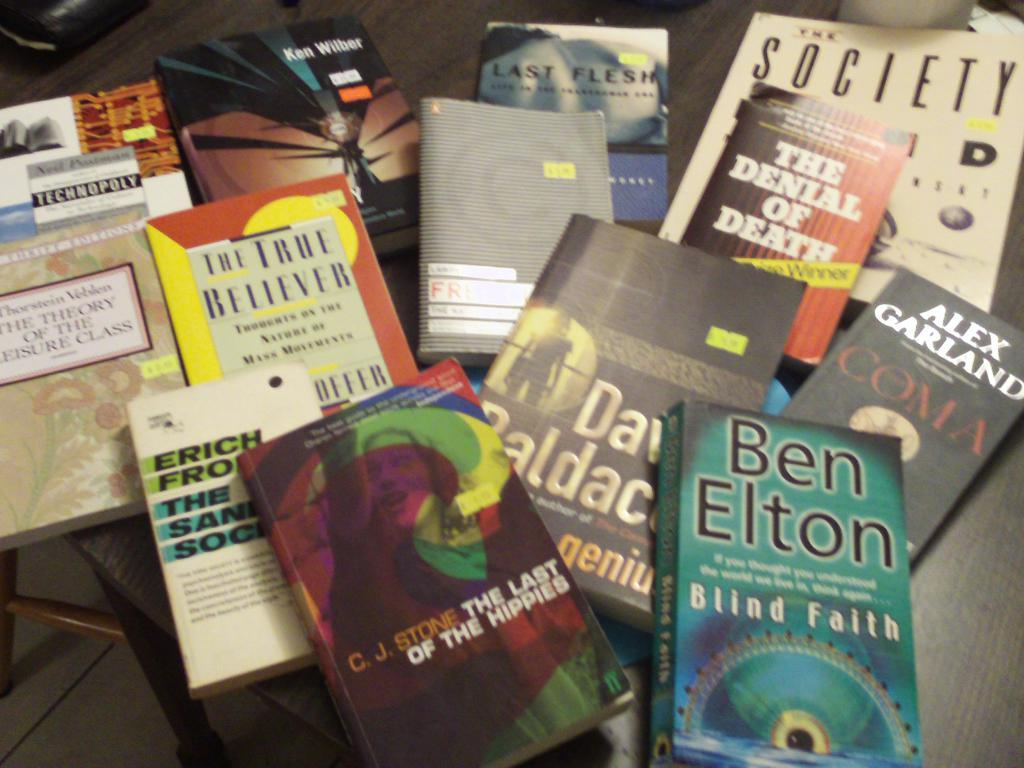<image>
Summarize the visual content of the image. A book by Ben Elton sits next to other books and pamphlets. 